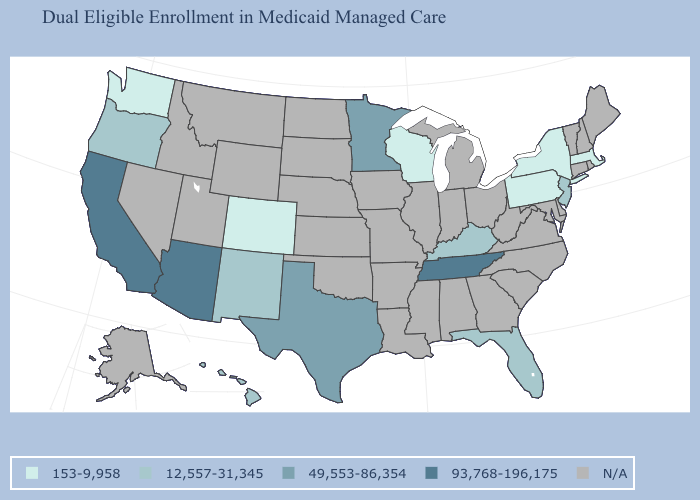Does Wisconsin have the lowest value in the MidWest?
Short answer required. Yes. Which states have the lowest value in the West?
Keep it brief. Colorado, Washington. Among the states that border Oregon , which have the lowest value?
Keep it brief. Washington. What is the value of New York?
Short answer required. 153-9,958. Among the states that border Pennsylvania , does New York have the highest value?
Quick response, please. No. Name the states that have a value in the range 12,557-31,345?
Quick response, please. Florida, Hawaii, Kentucky, New Jersey, New Mexico, Oregon. Does Arizona have the lowest value in the West?
Write a very short answer. No. Among the states that border Wyoming , which have the lowest value?
Give a very brief answer. Colorado. Does Oregon have the lowest value in the USA?
Keep it brief. No. Which states have the highest value in the USA?
Quick response, please. Arizona, California, Tennessee. What is the highest value in the Northeast ?
Keep it brief. 12,557-31,345. What is the lowest value in states that border Illinois?
Concise answer only. 153-9,958. Which states hav the highest value in the Northeast?
Be succinct. New Jersey. Name the states that have a value in the range 153-9,958?
Write a very short answer. Colorado, Massachusetts, New York, Pennsylvania, Washington, Wisconsin. 